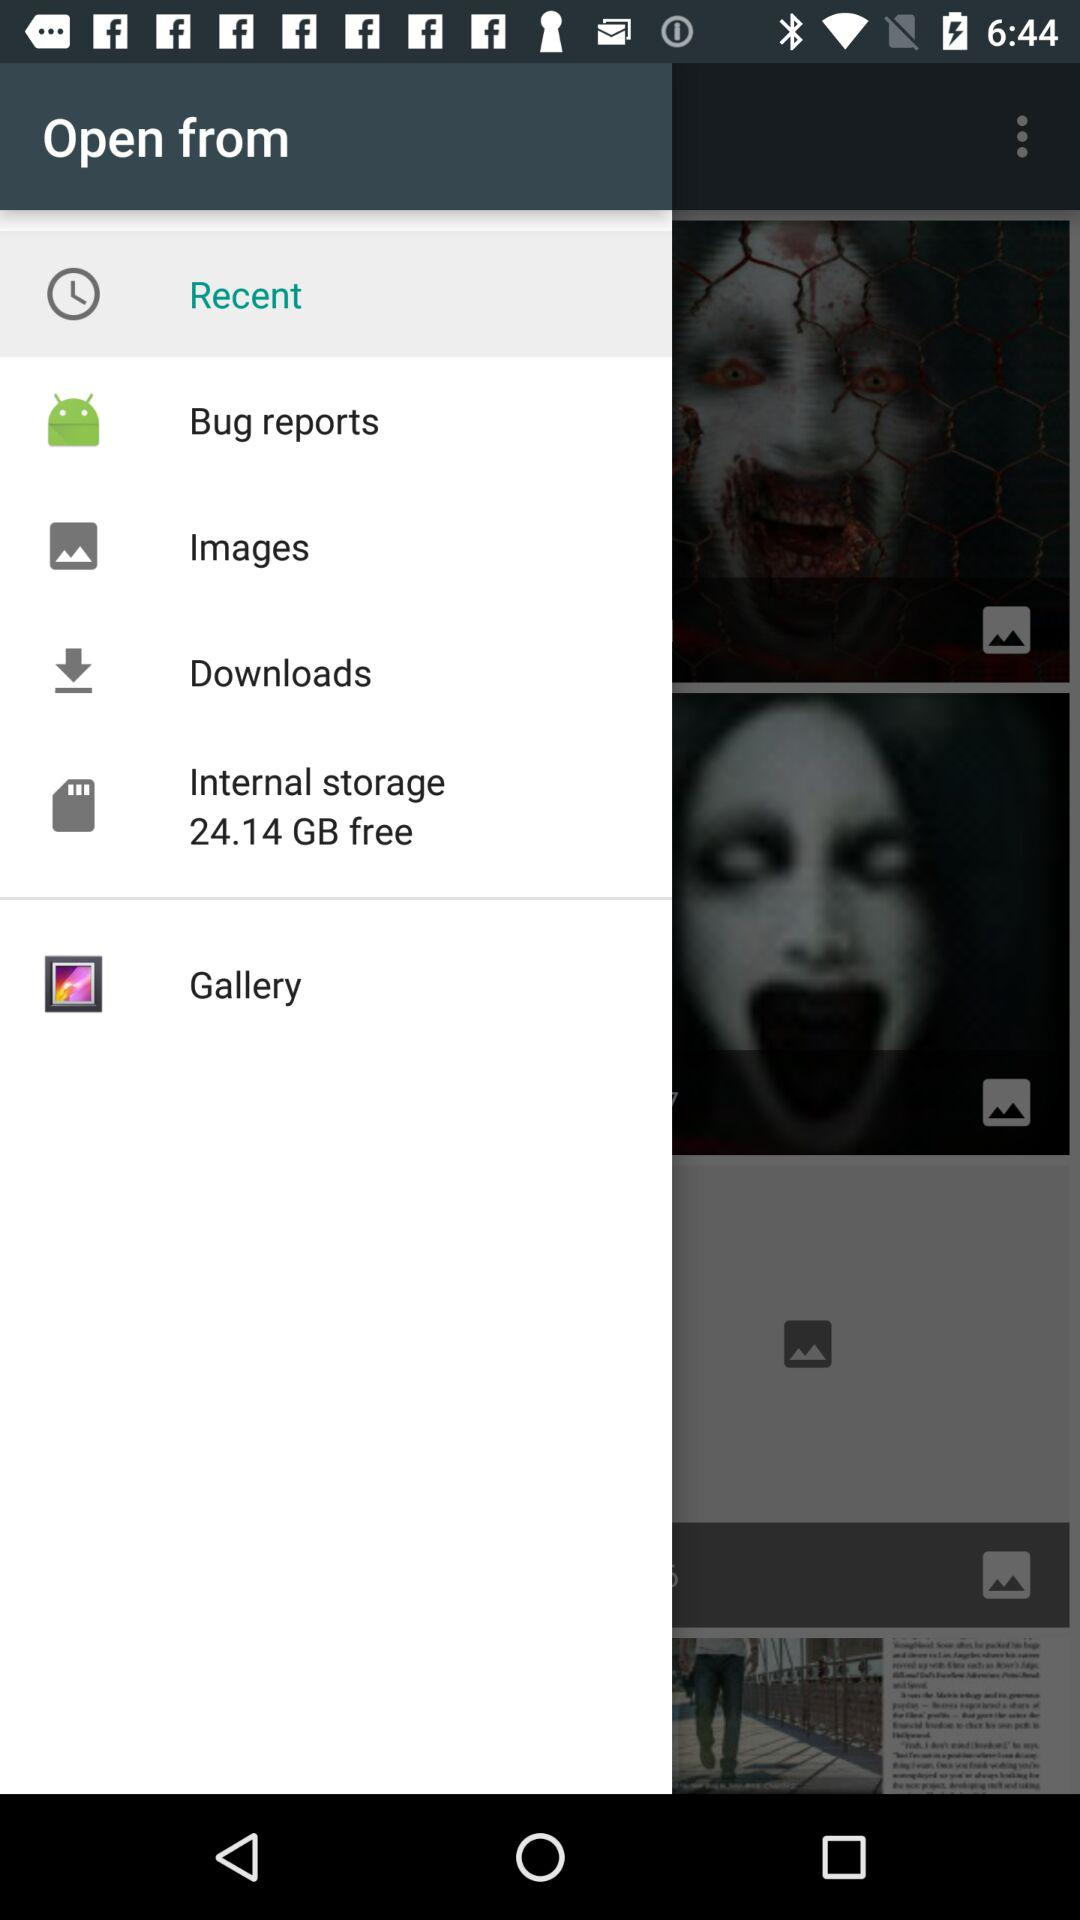How many items are downloaded?
When the provided information is insufficient, respond with <no answer>. <no answer> 